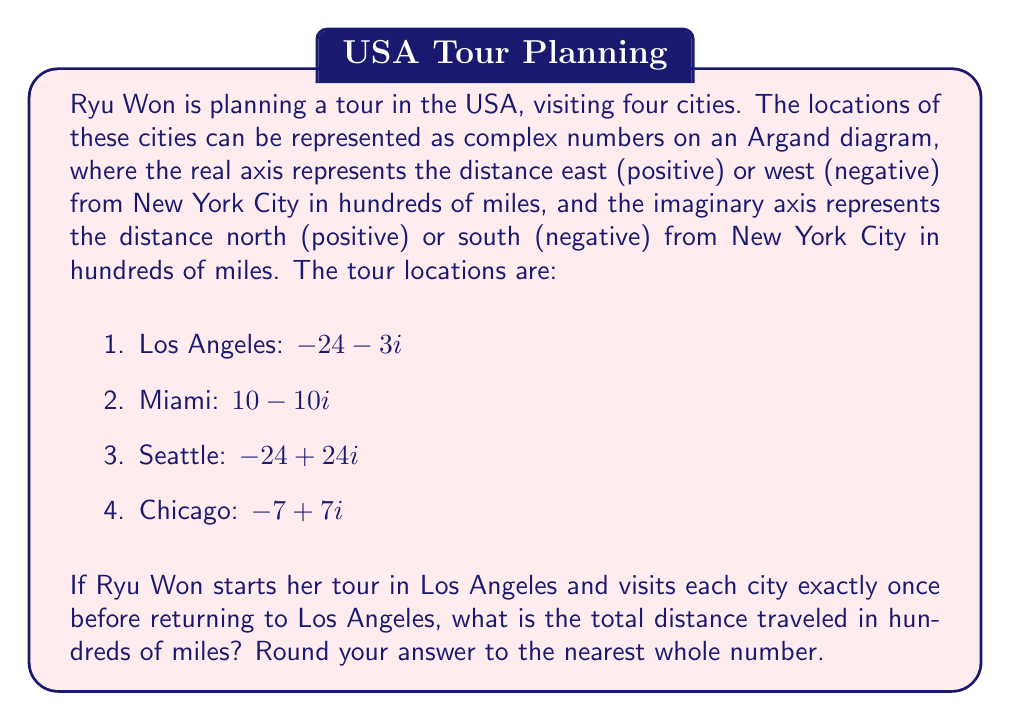Teach me how to tackle this problem. Let's approach this step-by-step:

1) First, we need to calculate the distance between each pair of cities. We can do this using the distance formula for complex numbers:

   $\text{distance} = |z_2 - z_1| = \sqrt{(x_2-x_1)^2 + (y_2-y_1)^2}$

2) Let's calculate each leg of the journey:

   a) Los Angeles to Miami:
      $|(-24-3i) - (10-10i)| = |(-34+7i)| = \sqrt{(-34)^2 + 7^2} = \sqrt{1205} \approx 34.71$

   b) Miami to Seattle:
      $|(10-10i) - (-24+24i)| = |(34-34i)| = \sqrt{34^2 + (-34)^2} = \sqrt{2312} \approx 48.08$

   c) Seattle to Chicago:
      $|(-24+24i) - (-7+7i)| = |(-17+17i)| = \sqrt{(-17)^2 + 17^2} = \sqrt{578} \approx 24.04$

   d) Chicago back to Los Angeles:
      $|(-7+7i) - (-24-3i)| = |(17-10i)| = \sqrt{17^2 + (-10)^2} = \sqrt{389} \approx 19.72$

3) Now, we sum up all these distances:

   Total distance = 34.71 + 48.08 + 24.04 + 19.72 = 126.55

4) Rounding to the nearest whole number:

   127 hundreds of miles
Answer: 127 